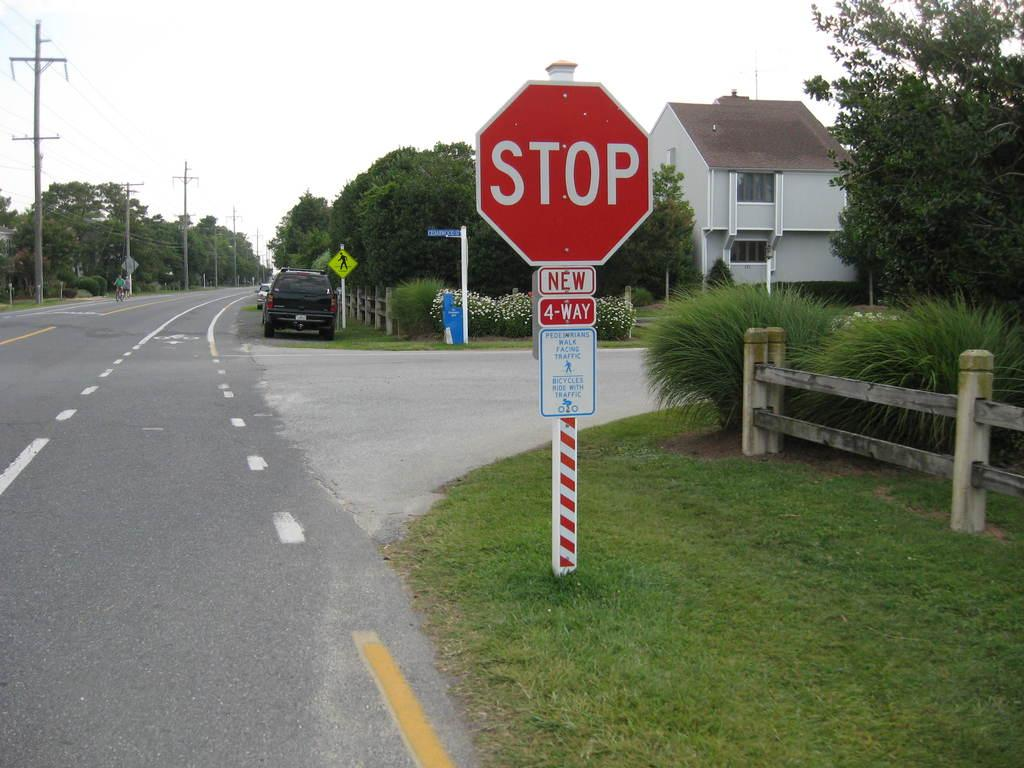Provide a one-sentence caption for the provided image. On the side of the road a STOP sign is sitting at a 4-WAY intersection. 